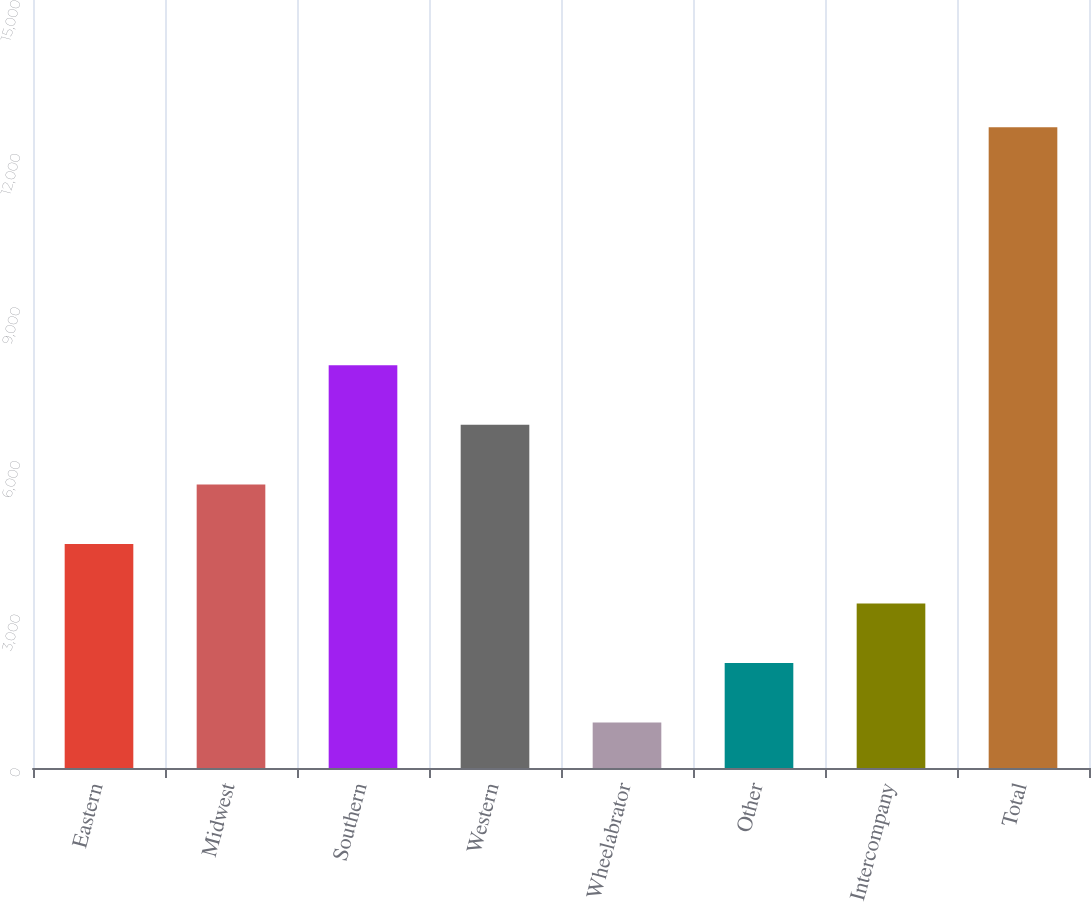Convert chart to OTSL. <chart><loc_0><loc_0><loc_500><loc_500><bar_chart><fcel>Eastern<fcel>Midwest<fcel>Southern<fcel>Western<fcel>Wheelabrator<fcel>Other<fcel>Intercompany<fcel>Total<nl><fcel>4376.8<fcel>5539.4<fcel>7864.6<fcel>6702<fcel>889<fcel>2051.6<fcel>3214.2<fcel>12515<nl></chart> 